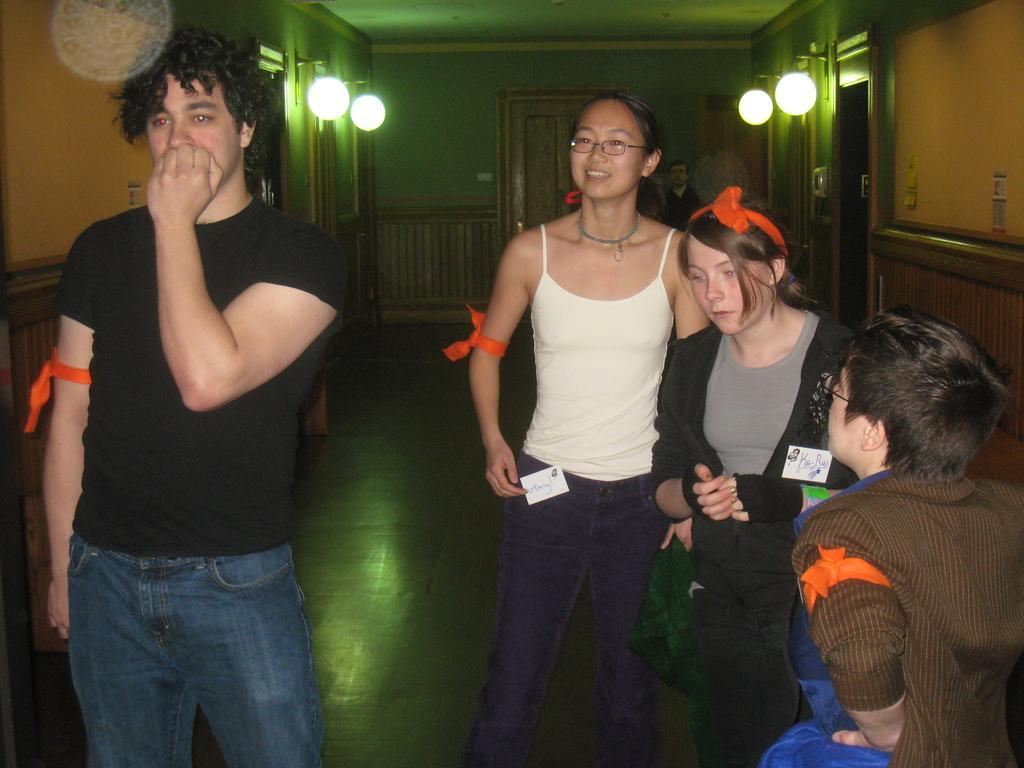How would you summarize this image in a sentence or two? In this image I can see a person wearing black t shirt, blue jeans and a woman wearing white top, blue jeans and few other persons are standing on the ground. In the background I can see few lights, a person's standing, the wall and the door. 